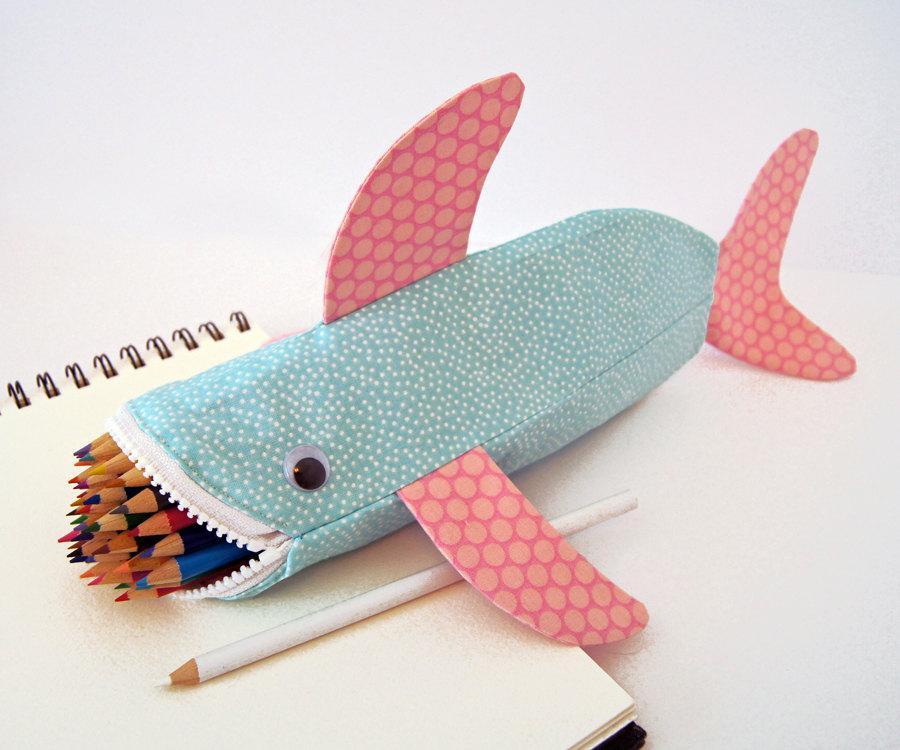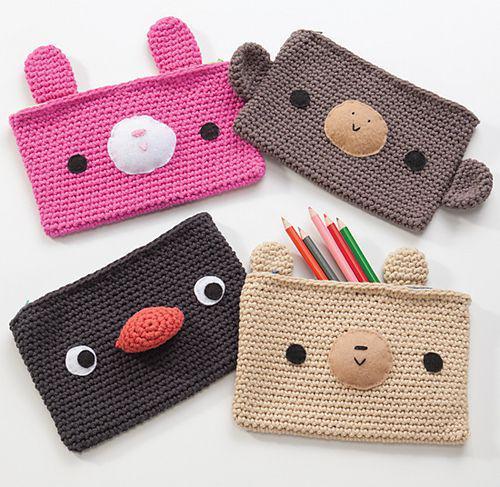The first image is the image on the left, the second image is the image on the right. Examine the images to the left and right. Is the description "All the pencil cases feature animal-inspired shapes." accurate? Answer yes or no. Yes. 